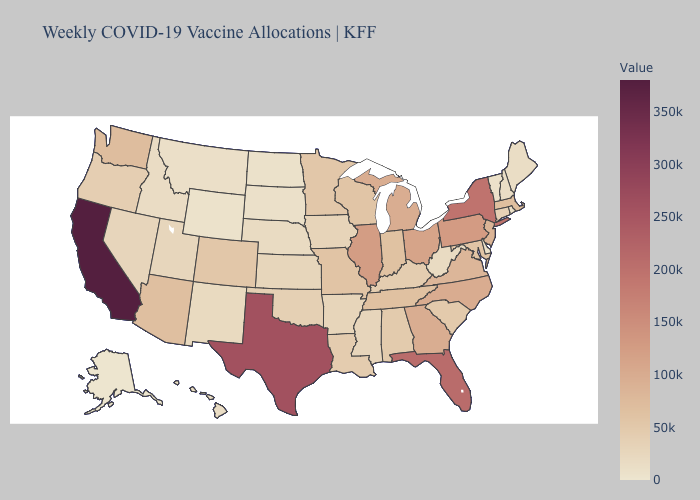Does Delaware have the lowest value in the USA?
Keep it brief. No. Does Tennessee have a higher value than Hawaii?
Concise answer only. Yes. Among the states that border Rhode Island , which have the highest value?
Answer briefly. Massachusetts. 